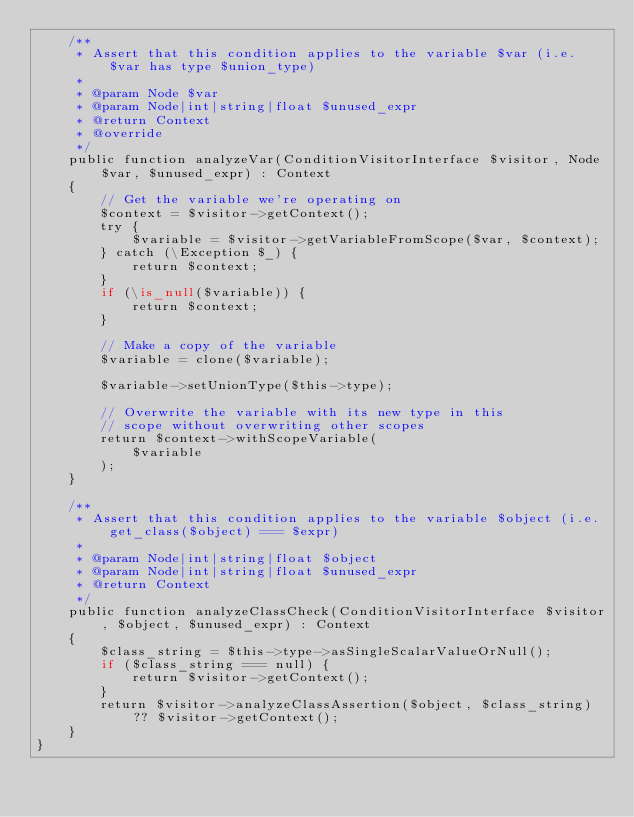Convert code to text. <code><loc_0><loc_0><loc_500><loc_500><_PHP_>    /**
     * Assert that this condition applies to the variable $var (i.e. $var has type $union_type)
     *
     * @param Node $var
     * @param Node|int|string|float $unused_expr
     * @return Context
     * @override
     */
    public function analyzeVar(ConditionVisitorInterface $visitor, Node $var, $unused_expr) : Context
    {
        // Get the variable we're operating on
        $context = $visitor->getContext();
        try {
            $variable = $visitor->getVariableFromScope($var, $context);
        } catch (\Exception $_) {
            return $context;
        }
        if (\is_null($variable)) {
            return $context;
        }

        // Make a copy of the variable
        $variable = clone($variable);

        $variable->setUnionType($this->type);

        // Overwrite the variable with its new type in this
        // scope without overwriting other scopes
        return $context->withScopeVariable(
            $variable
        );
    }

    /**
     * Assert that this condition applies to the variable $object (i.e. get_class($object) === $expr)
     *
     * @param Node|int|string|float $object
     * @param Node|int|string|float $unused_expr
     * @return Context
     */
    public function analyzeClassCheck(ConditionVisitorInterface $visitor, $object, $unused_expr) : Context
    {
        $class_string = $this->type->asSingleScalarValueOrNull();
        if ($class_string === null) {
            return $visitor->getContext();
        }
        return $visitor->analyzeClassAssertion($object, $class_string) ?? $visitor->getContext();
    }
}
</code> 